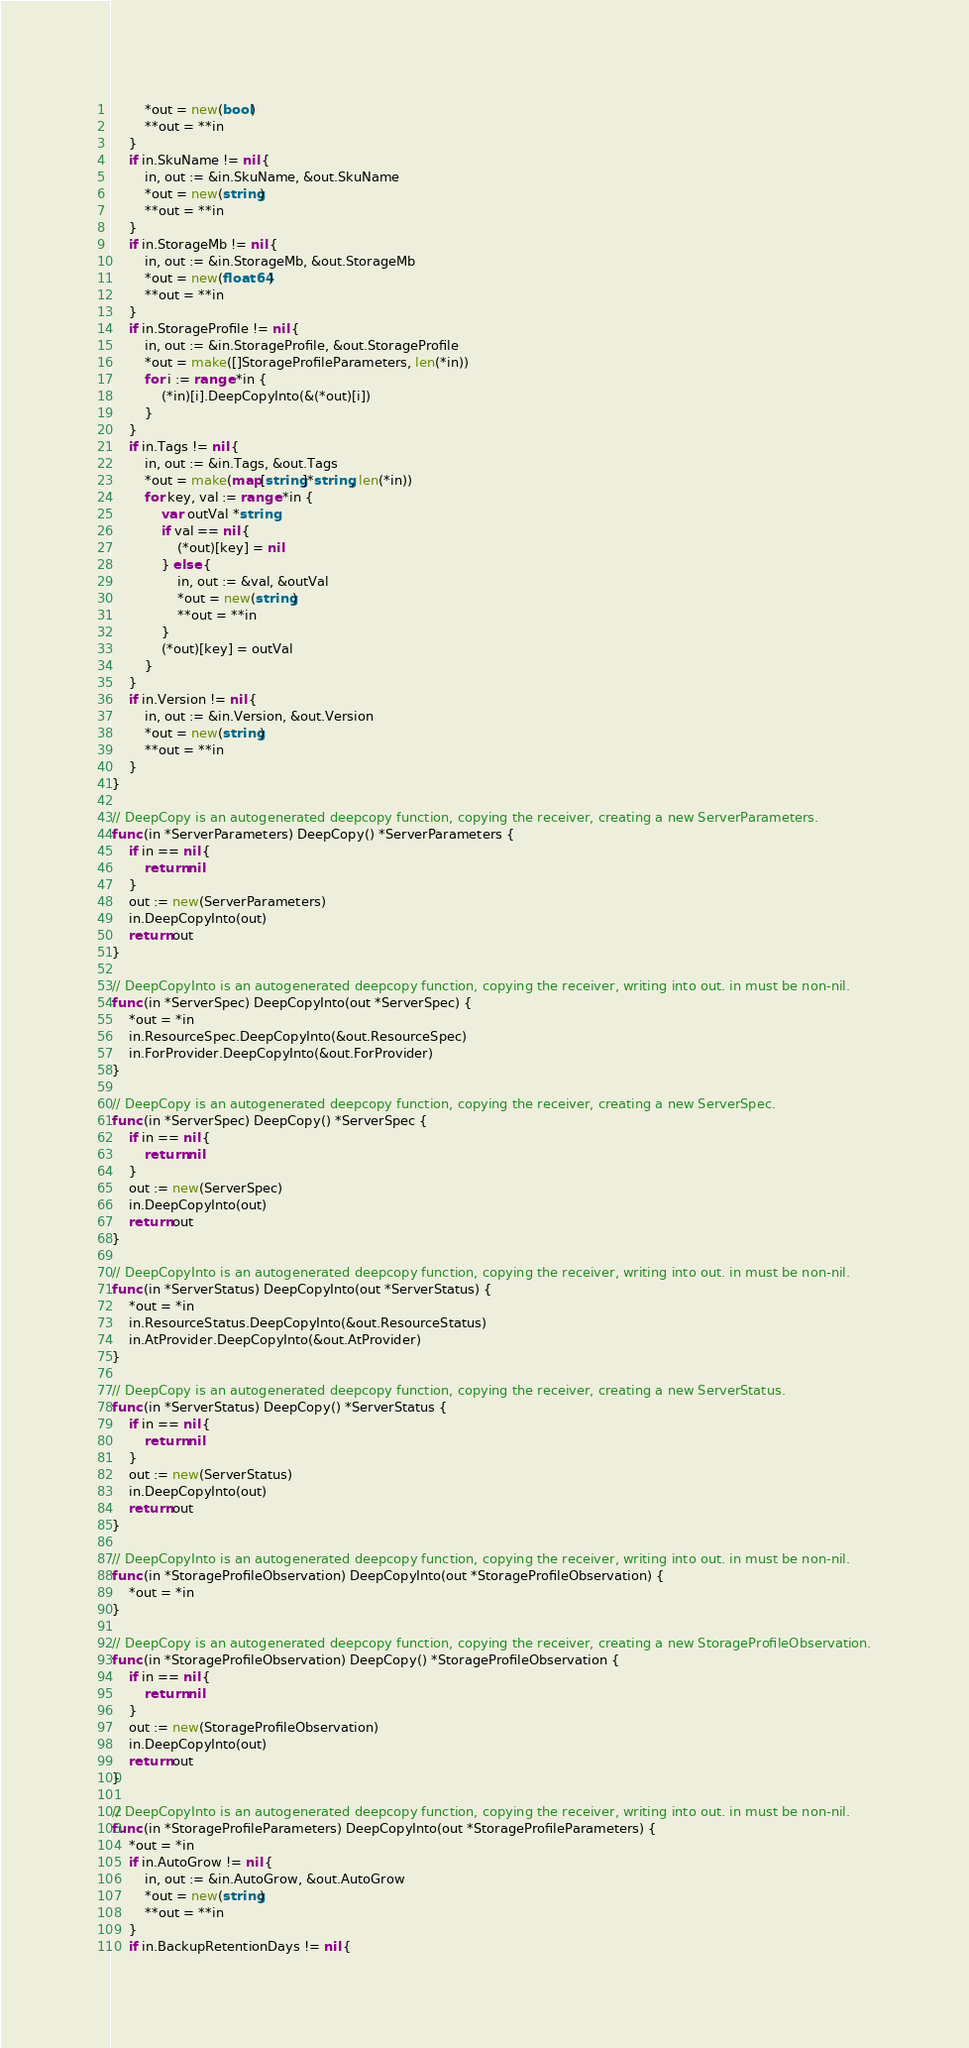Convert code to text. <code><loc_0><loc_0><loc_500><loc_500><_Go_>		*out = new(bool)
		**out = **in
	}
	if in.SkuName != nil {
		in, out := &in.SkuName, &out.SkuName
		*out = new(string)
		**out = **in
	}
	if in.StorageMb != nil {
		in, out := &in.StorageMb, &out.StorageMb
		*out = new(float64)
		**out = **in
	}
	if in.StorageProfile != nil {
		in, out := &in.StorageProfile, &out.StorageProfile
		*out = make([]StorageProfileParameters, len(*in))
		for i := range *in {
			(*in)[i].DeepCopyInto(&(*out)[i])
		}
	}
	if in.Tags != nil {
		in, out := &in.Tags, &out.Tags
		*out = make(map[string]*string, len(*in))
		for key, val := range *in {
			var outVal *string
			if val == nil {
				(*out)[key] = nil
			} else {
				in, out := &val, &outVal
				*out = new(string)
				**out = **in
			}
			(*out)[key] = outVal
		}
	}
	if in.Version != nil {
		in, out := &in.Version, &out.Version
		*out = new(string)
		**out = **in
	}
}

// DeepCopy is an autogenerated deepcopy function, copying the receiver, creating a new ServerParameters.
func (in *ServerParameters) DeepCopy() *ServerParameters {
	if in == nil {
		return nil
	}
	out := new(ServerParameters)
	in.DeepCopyInto(out)
	return out
}

// DeepCopyInto is an autogenerated deepcopy function, copying the receiver, writing into out. in must be non-nil.
func (in *ServerSpec) DeepCopyInto(out *ServerSpec) {
	*out = *in
	in.ResourceSpec.DeepCopyInto(&out.ResourceSpec)
	in.ForProvider.DeepCopyInto(&out.ForProvider)
}

// DeepCopy is an autogenerated deepcopy function, copying the receiver, creating a new ServerSpec.
func (in *ServerSpec) DeepCopy() *ServerSpec {
	if in == nil {
		return nil
	}
	out := new(ServerSpec)
	in.DeepCopyInto(out)
	return out
}

// DeepCopyInto is an autogenerated deepcopy function, copying the receiver, writing into out. in must be non-nil.
func (in *ServerStatus) DeepCopyInto(out *ServerStatus) {
	*out = *in
	in.ResourceStatus.DeepCopyInto(&out.ResourceStatus)
	in.AtProvider.DeepCopyInto(&out.AtProvider)
}

// DeepCopy is an autogenerated deepcopy function, copying the receiver, creating a new ServerStatus.
func (in *ServerStatus) DeepCopy() *ServerStatus {
	if in == nil {
		return nil
	}
	out := new(ServerStatus)
	in.DeepCopyInto(out)
	return out
}

// DeepCopyInto is an autogenerated deepcopy function, copying the receiver, writing into out. in must be non-nil.
func (in *StorageProfileObservation) DeepCopyInto(out *StorageProfileObservation) {
	*out = *in
}

// DeepCopy is an autogenerated deepcopy function, copying the receiver, creating a new StorageProfileObservation.
func (in *StorageProfileObservation) DeepCopy() *StorageProfileObservation {
	if in == nil {
		return nil
	}
	out := new(StorageProfileObservation)
	in.DeepCopyInto(out)
	return out
}

// DeepCopyInto is an autogenerated deepcopy function, copying the receiver, writing into out. in must be non-nil.
func (in *StorageProfileParameters) DeepCopyInto(out *StorageProfileParameters) {
	*out = *in
	if in.AutoGrow != nil {
		in, out := &in.AutoGrow, &out.AutoGrow
		*out = new(string)
		**out = **in
	}
	if in.BackupRetentionDays != nil {</code> 